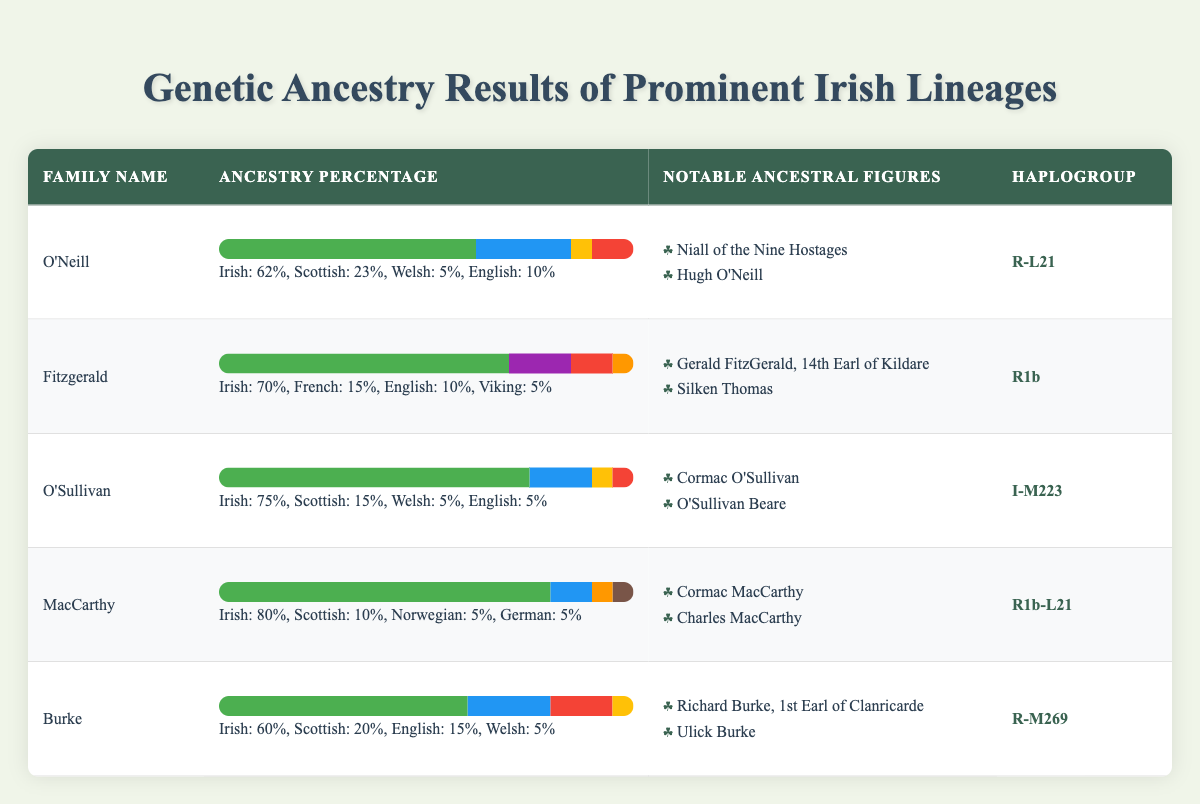What is the ancestry percentage of the O'Neill family? The table lists the ancestry percentages for the O'Neill family. It shows that they have 62% Irish, 23% Scottish, 5% Welsh, and 10% English.
Answer: 62% Irish, 23% Scottish, 5% Welsh, 10% English Which family has the highest percentage of Irish ancestry? Looking at the table, the family with the highest percentage of Irish ancestry is the MacCarthy family with 80% Irish.
Answer: MacCarthy True or false: The Fitzgerald family has more French ancestry than English ancestry. The table indicates that the Fitzgerald family has 15% French and 10% English ancestry. Since 15% is greater than 10%, the statement is true.
Answer: True What is the average percentage of Scottish ancestry across all families? To find the average percentage of Scottish ancestry, we sum the Scottish percentages of all families: (23 + 15 + 15 + 10 + 20) = 83%. There are 5 families, so the average is 83% / 5 = 16.6%.
Answer: 16.6% Which family's notable ancestral figures include 'Silken Thomas'? The table indicates that the notable ancestral figures of the Fitzgerald family include 'Silken Thomas'.
Answer: Fitzgerald How much higher is the Irish ancestry percentage of the O'Sullivan family compared to the Burke family? The O'Sullivan family has 75% Irish ancestry, while the Burke family has 60%. The difference is 75% - 60% = 15%.
Answer: 15% True or false: The haplogroup R1b is found in both the Fitzgerald and MacCarthy families. The table shows that the Fitzgerald family's haplogroup is R1b, and the MacCarthy family's haplogroup is R1b-L21. Since both haplogroups share R1b, the statement is true.
Answer: True 